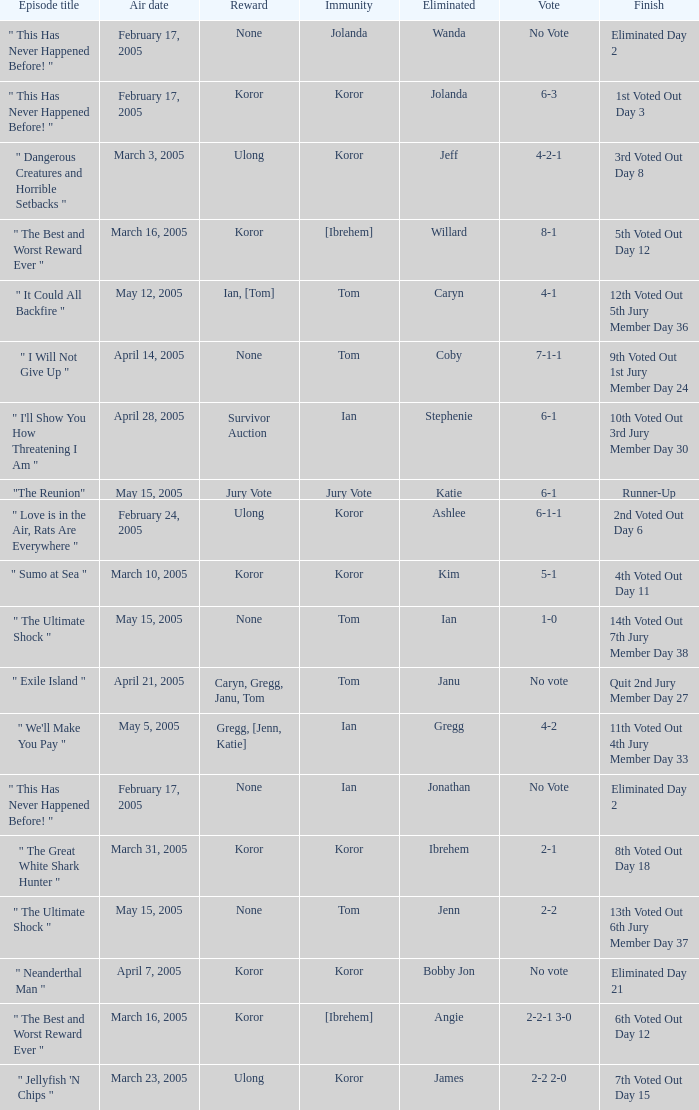What was the vote tally on the episode aired May 5, 2005? 4-2. 